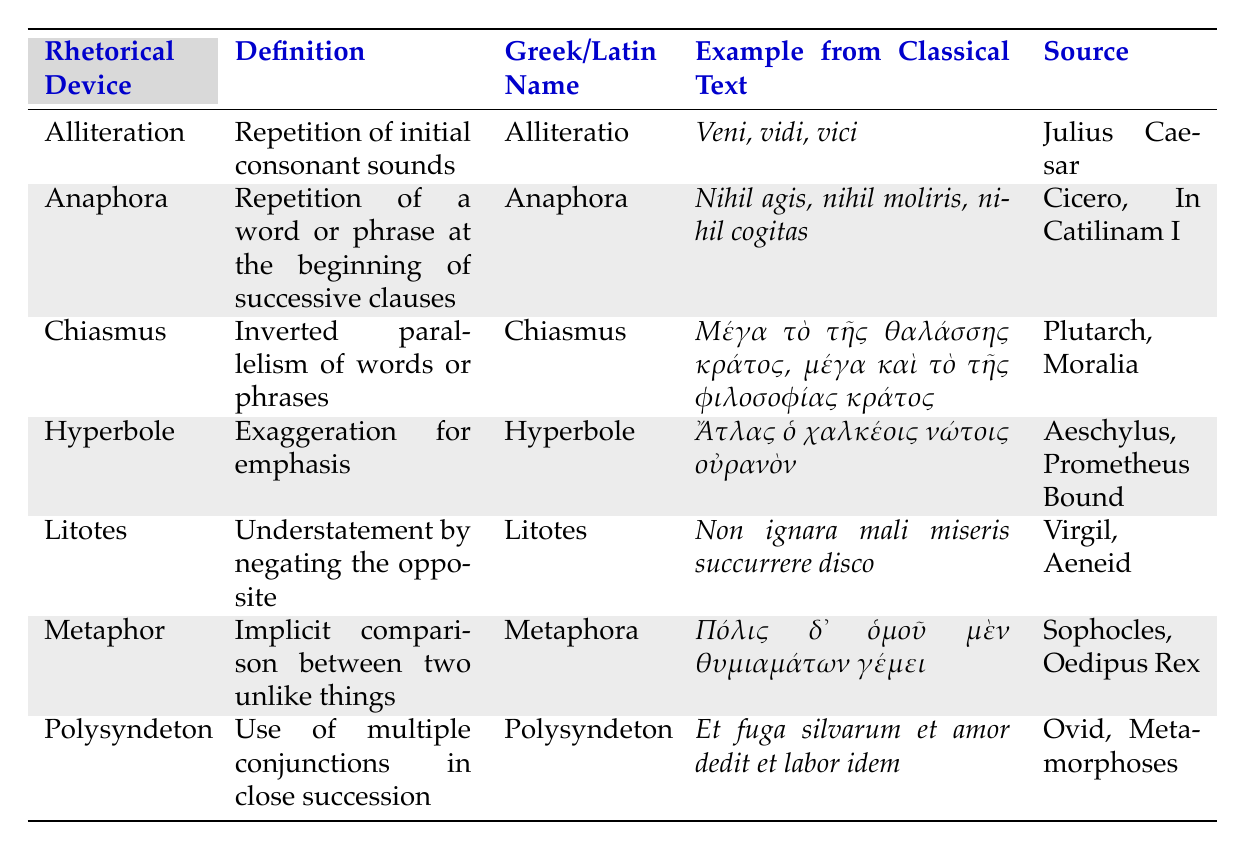What is the Greek name for Hyperbole? The table lists the Greek/Latin names in the third column. For Hyperbole, the Greek/Latin name is Hyperbole.
Answer: Hyperbole Which rhetorical device is defined as an understatement by negating the opposite? The definition columns provide the explanations for each rhetorical device, and the device defined as an understatement by negating the opposite is Litotes.
Answer: Litotes How many examples of rhetorical devices are sourced from classical texts authored by Cicero? There is one row under the source column that mentions Cicero, which is for the rhetorical device Anaphora.
Answer: 1 Does the example for Polysyndeton contain alliteration? The example for Polysyndeton is "Et fuga silvarum et amor dedit et labor idem". Alliteration involves the repetition of initial consonant sounds, and this phrase does not feature such repetition.
Answer: No Which rhetorical device exemplifies inverted parallelism of words or phrases? Referring to the definition of each device, Chiasmus is described as inverted parallelism of words or phrases.
Answer: Chiasmus What is the definition of Anaphora? By looking in the second column for Anaphora, we see that it is defined as the repetition of a word or phrase at the beginning of successive clauses.
Answer: Repetition of a word or phrase at the beginning of successive clauses Is there a rhetorical device that uses multiple conjunctions in succession? The definition column reveals that Polysyndeton describes the use of multiple conjunctions in close succession.
Answer: Yes What rhetorical device features an example from Aeschylus? The source column indicates that Hyperbole uses an example from Aeschylus, as it states "Aeschylus, Prometheus Bound".
Answer: Hyperbole Which rhetorical devices have Latin names that are the same as their English names? By examining the Greek/Latin name and Rhetorical Device columns, both Hyperbole and Anaphora have the same name in Latin as they do in English.
Answer: Hyperbole and Anaphora What type of rhetorical device is an implicit comparison between two unlike things? The definition for Metaphor indicates that it is an implicit comparison between two unlike things.
Answer: Metaphor How many rhetorical devices listed have examples from the work of Sophocles? The only rhetorical device with an example from Sophocles is Metaphor, as indicated in the source column.
Answer: 1 